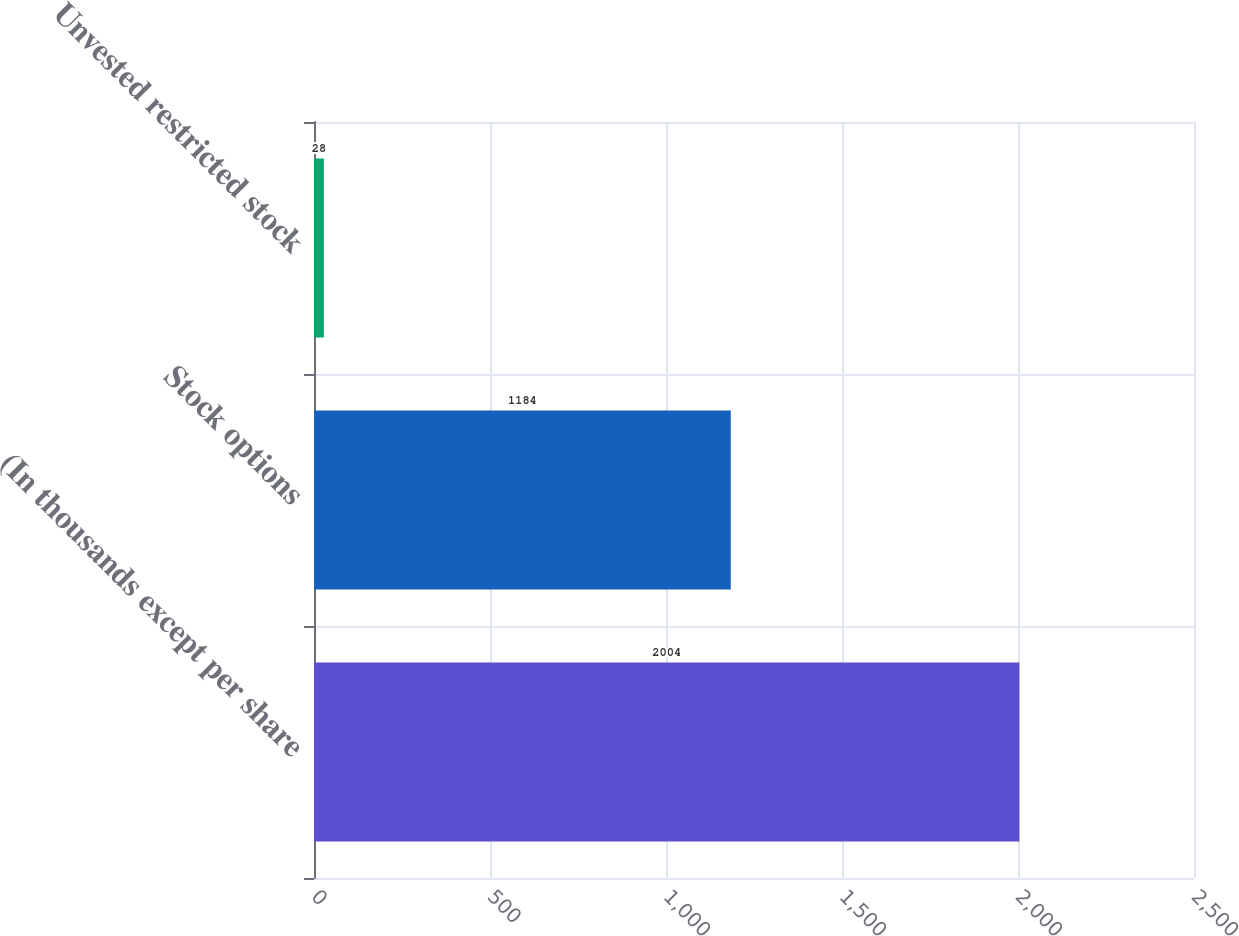Convert chart. <chart><loc_0><loc_0><loc_500><loc_500><bar_chart><fcel>(In thousands except per share<fcel>Stock options<fcel>Unvested restricted stock<nl><fcel>2004<fcel>1184<fcel>28<nl></chart> 